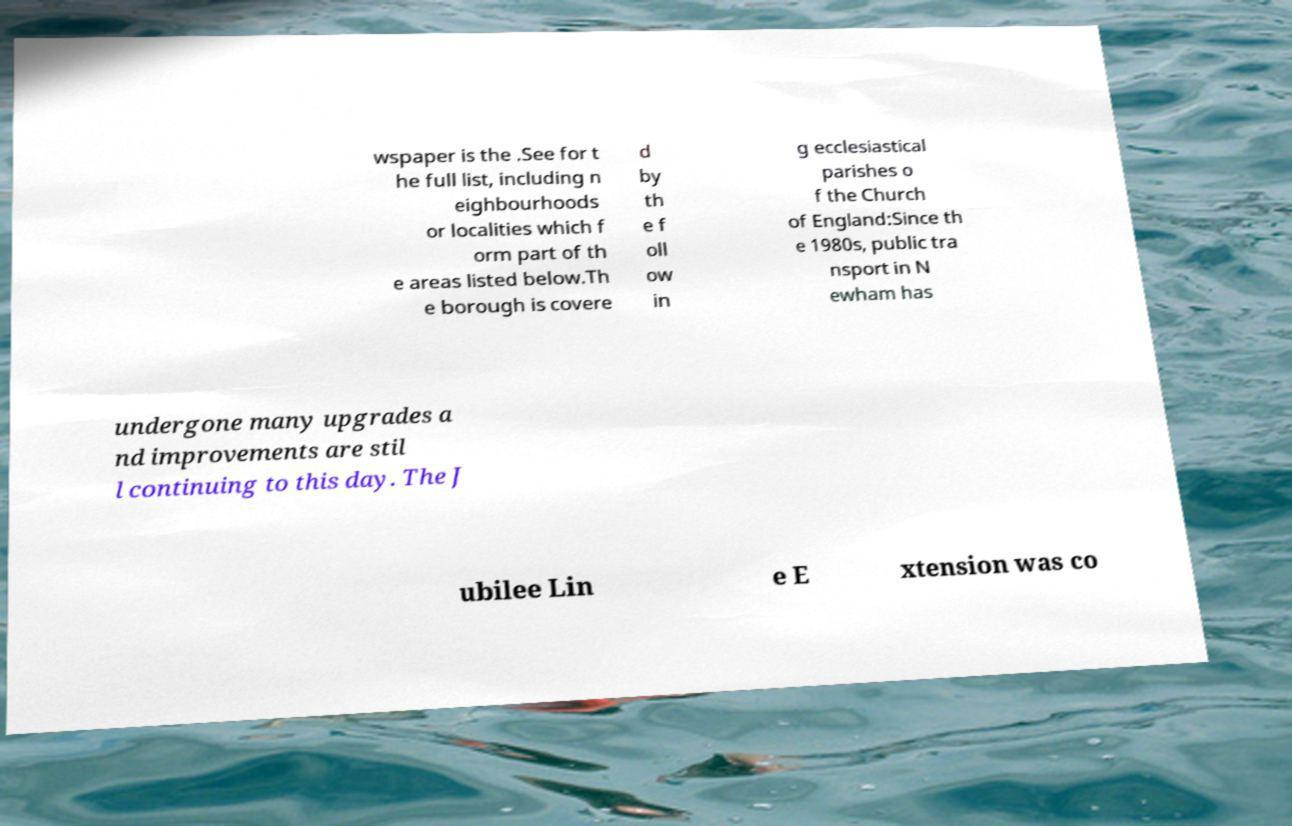Please identify and transcribe the text found in this image. wspaper is the .See for t he full list, including n eighbourhoods or localities which f orm part of th e areas listed below.Th e borough is covere d by th e f oll ow in g ecclesiastical parishes o f the Church of England:Since th e 1980s, public tra nsport in N ewham has undergone many upgrades a nd improvements are stil l continuing to this day. The J ubilee Lin e E xtension was co 